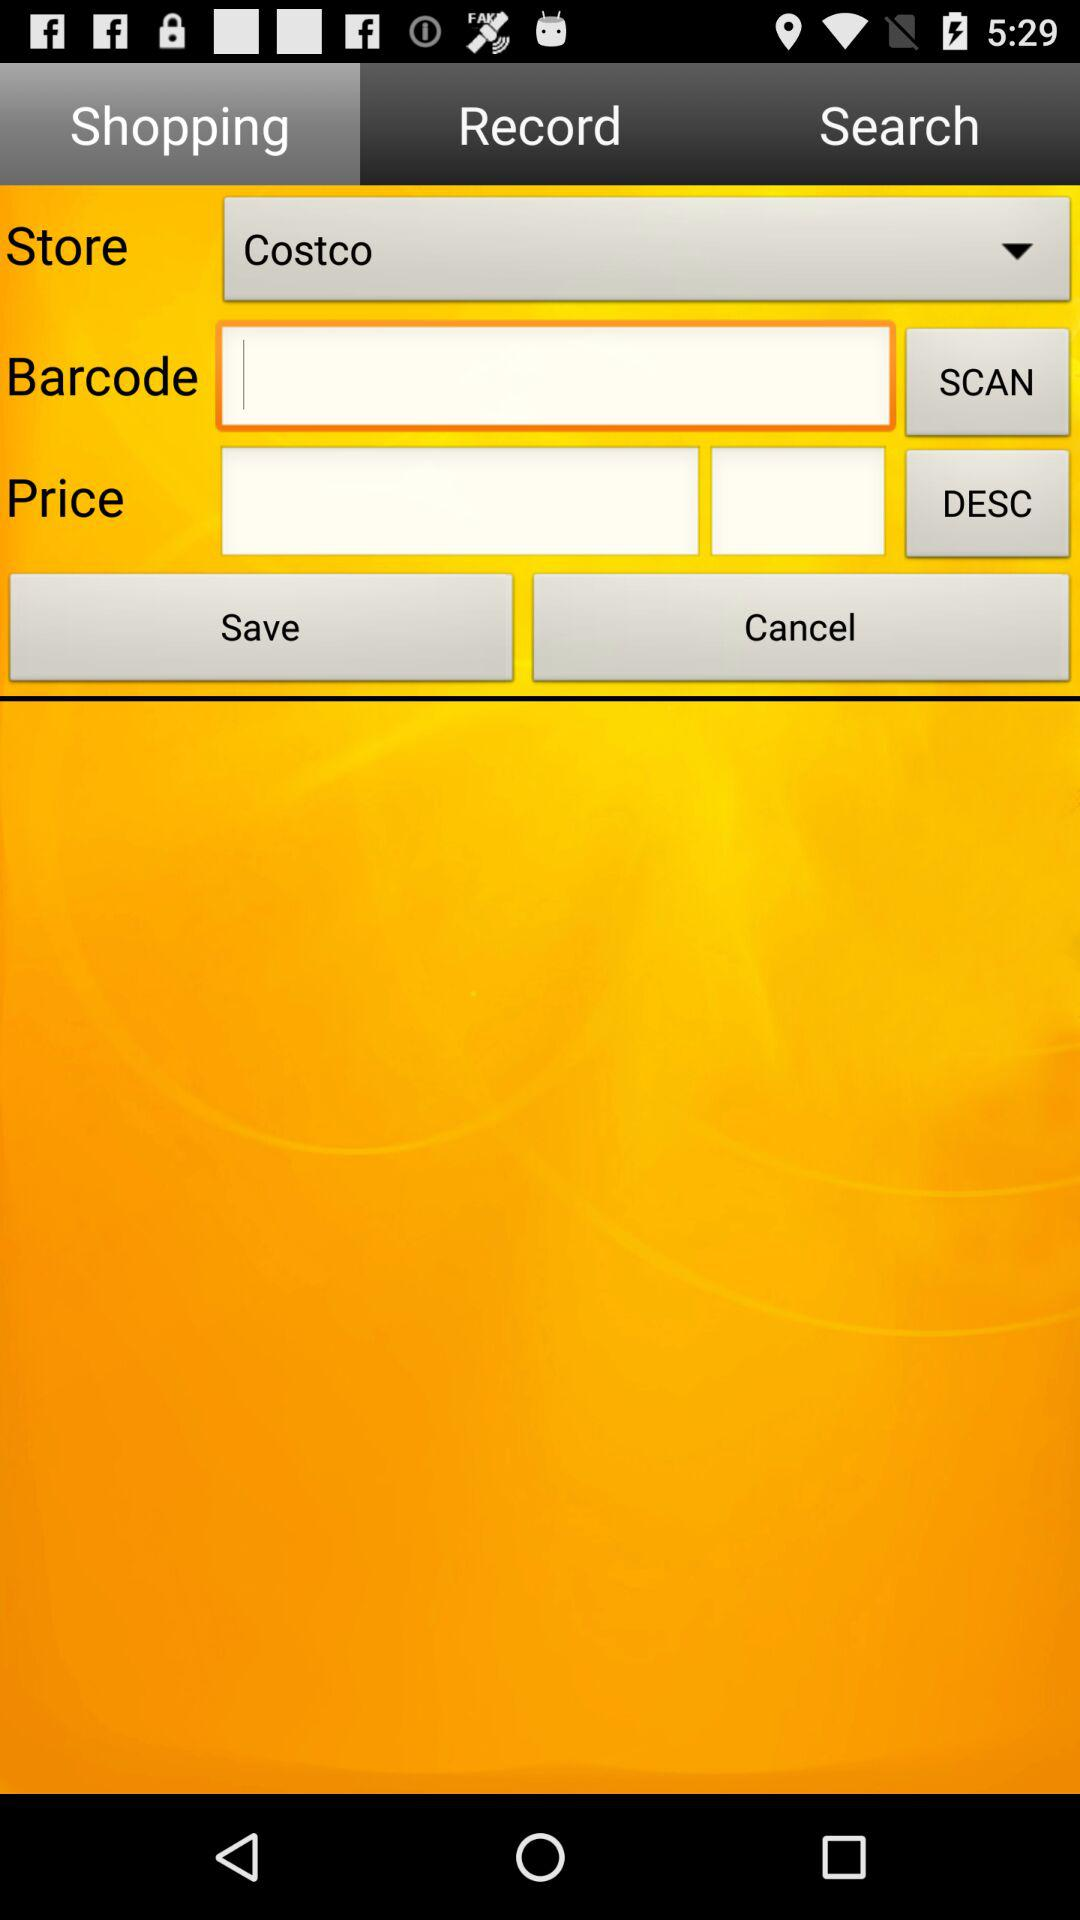Which store is selected? The selected store is "Costco". 